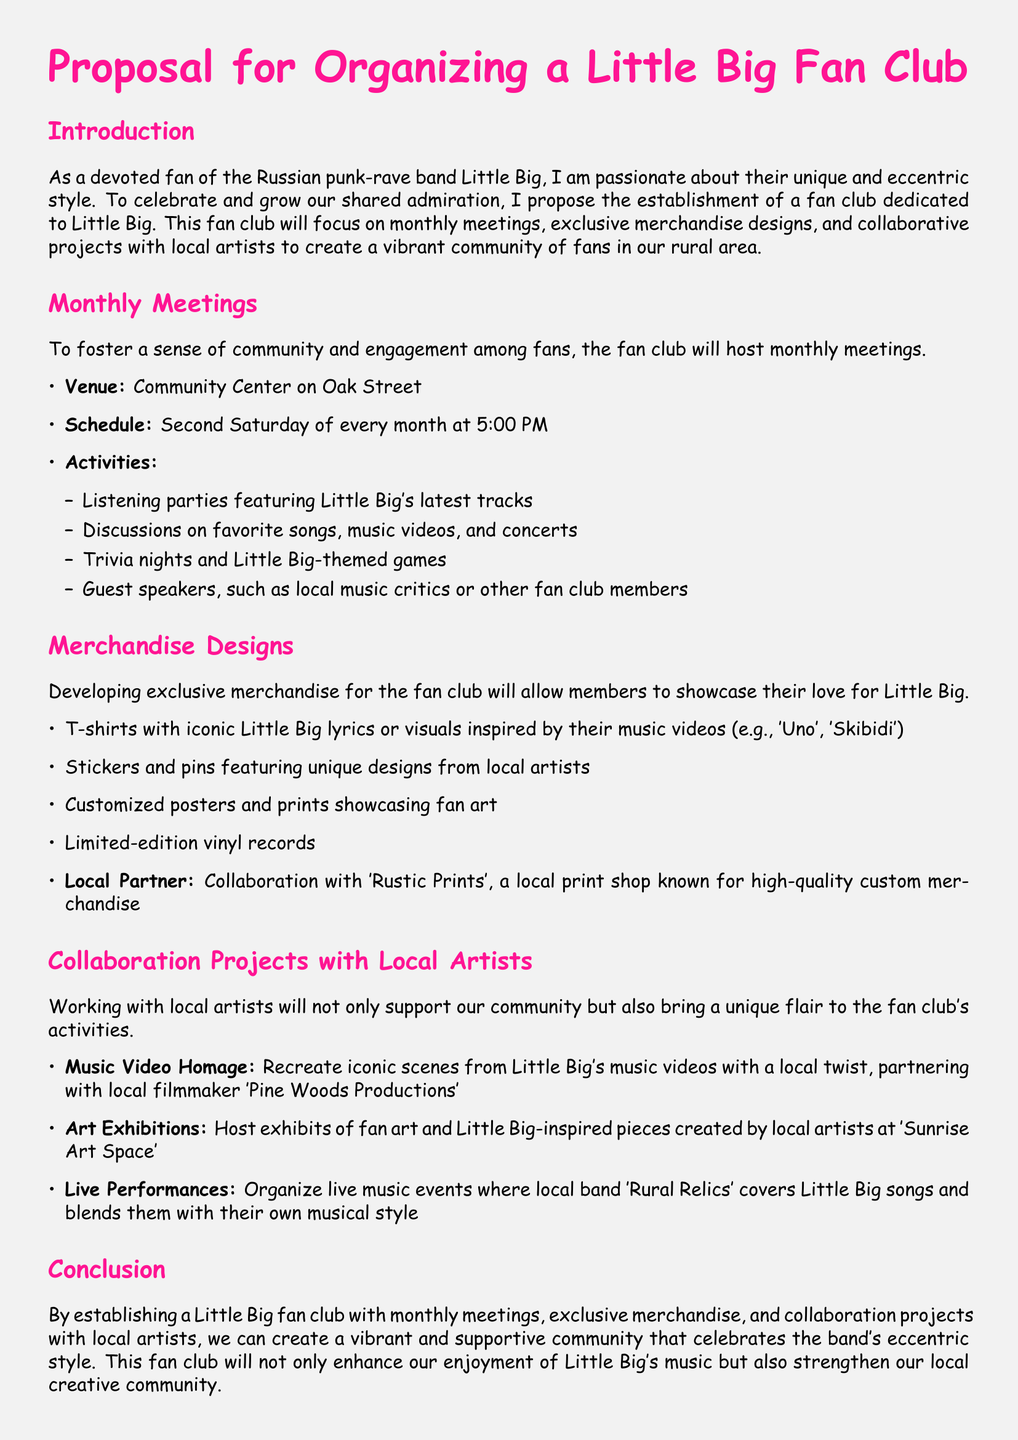What is the proposed venue for monthly meetings? The proposed venue is the Community Center on Oak Street.
Answer: Community Center on Oak Street When will the meetings be held each month? The meetings are scheduled for the second Saturday of every month at 5:00 PM.
Answer: Second Saturday of every month at 5:00 PM What type of merchandise will be developed for the fan club? The merchandise includes T-shirts, stickers, pins, customized posters, and vinyl records.
Answer: T-shirts, stickers, pins, customized posters, and vinyl records Who is the local partner for merchandise designs? The local partner mentioned for merchandise designs is 'Rustic Prints'.
Answer: Rustic Prints What is one proposed collaboration project with local artists? One proposed collaboration project is to recreate iconic scenes from Little Big's music videos.
Answer: Recreate iconic scenes from Little Big's music videos What is the goal of establishing a Little Big fan club? The goal is to create a vibrant and supportive community celebrating the band's eccentric style.
Answer: Create a vibrant and supportive community How will the fan club enhance local creative community? The fan club will strengthen the local creative community through collaboration with local artists.
Answer: Strengthen local creative community What is a type of activity planned for the monthly meetings? Activities planned include listening parties featuring Little Big's latest tracks.
Answer: Listening parties featuring Little Big's latest tracks 